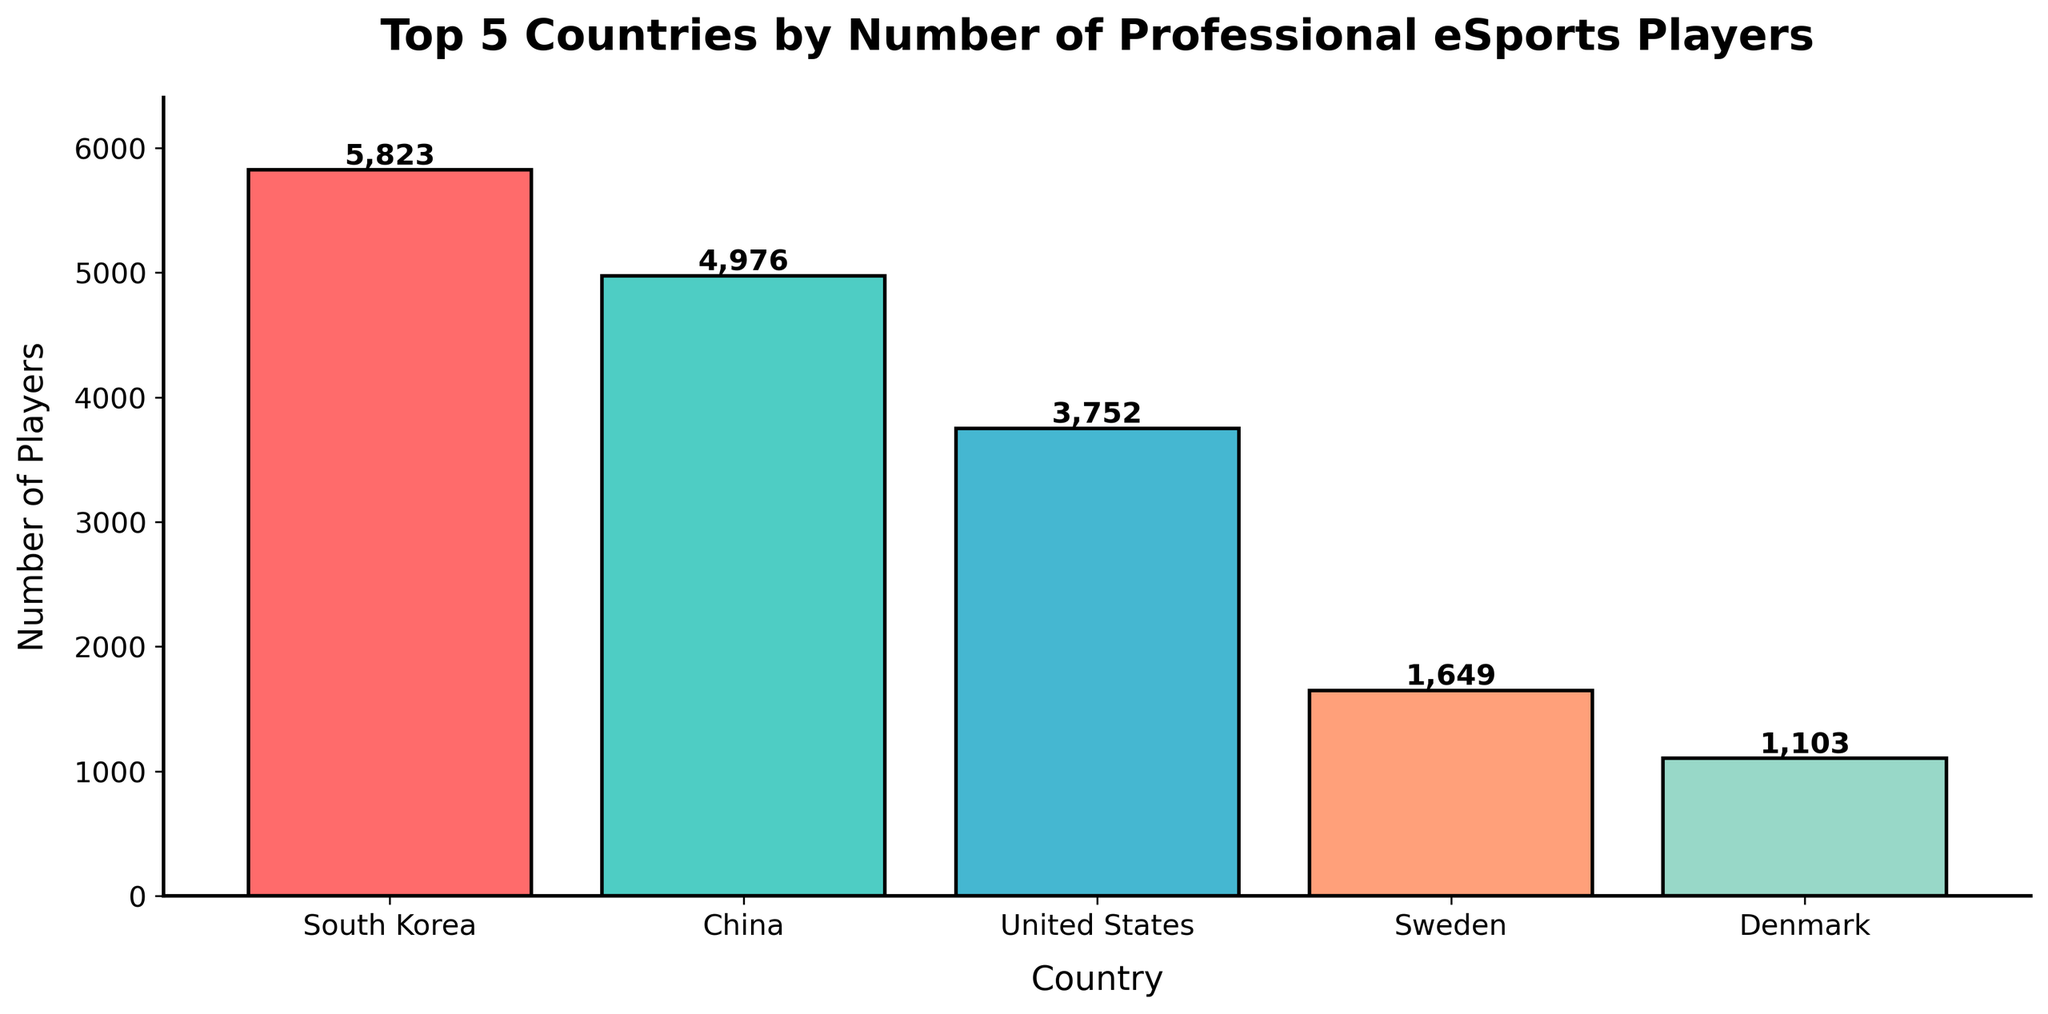What is the country with the highest number of professional eSports players? The country with the highest bar represents the highest number of professional eSports players. In the given chart, South Korea has the tallest bar.
Answer: South Korea What is the difference in the number of professional eSports players between South Korea and China? Subtract the number of professional eSports players in China (4,976) from that in South Korea (5,823). 5,823 - 4,976 = 847
Answer: 847 Which country has fewer professional eSports players, Sweden or Denmark? Compare the height of the bars for Sweden and Denmark. Sweden has 1,649 players, and Denmark has 1,103 players, so Denmark has fewer.
Answer: Denmark How many more professional eSports players does the United States have compared to Denmark? Subtract the number of professional eSports players in Denmark (1,103) from the number in the United States (3,752). 3,752 - 1,103 = 2,649
Answer: 2,649 What are the respective colors of the bars representing China and Sweden? The bar for China is the second one (from the left) and is colored teal, while the bar for Sweden is the fourth and is colored light orange.
Answer: Teal and Light Orange What is the total number of professional eSports players in the top 5 countries combined? Sum the number of players in all top 5 countries: South Korea (5,823) + China (4,976) + United States (3,752) + Sweden (1,649) + Denmark (1,103). The total is 17,303
Answer: 17,303 Which country has just over 3,500 professional eSports players? The United States has 3,752 professional eSports players, which is just over 3,500.
Answer: United States Which two countries have professional eSports player counts both below 2,000? Sweden (1,649) and Denmark (1,103) both have counts below 2,000.
Answer: Sweden and Denmark What's the average number of professional eSports players in these top 5 countries? First, sum the number of players: 5,823 (South Korea) + 4,976 (China) + 3,752 (USA) + 1,649 (Sweden) + 1,103 (Denmark) = 17,303. Then, divide by 5 (number of countries). 17,303 / 5 = 3,460.6
Answer: 3,460.6 How much taller is the bar representing South Korea than the bar representing the United States? Subtract the height (number of players) of the United States (3,752) from South Korea (5,823). 5,823 - 3,752 = 2,071
Answer: 2,071 